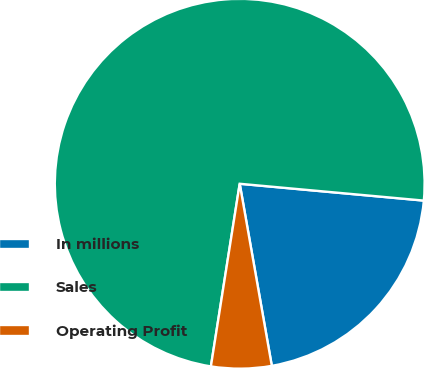<chart> <loc_0><loc_0><loc_500><loc_500><pie_chart><fcel>In millions<fcel>Sales<fcel>Operating Profit<nl><fcel>20.77%<fcel>73.96%<fcel>5.27%<nl></chart> 